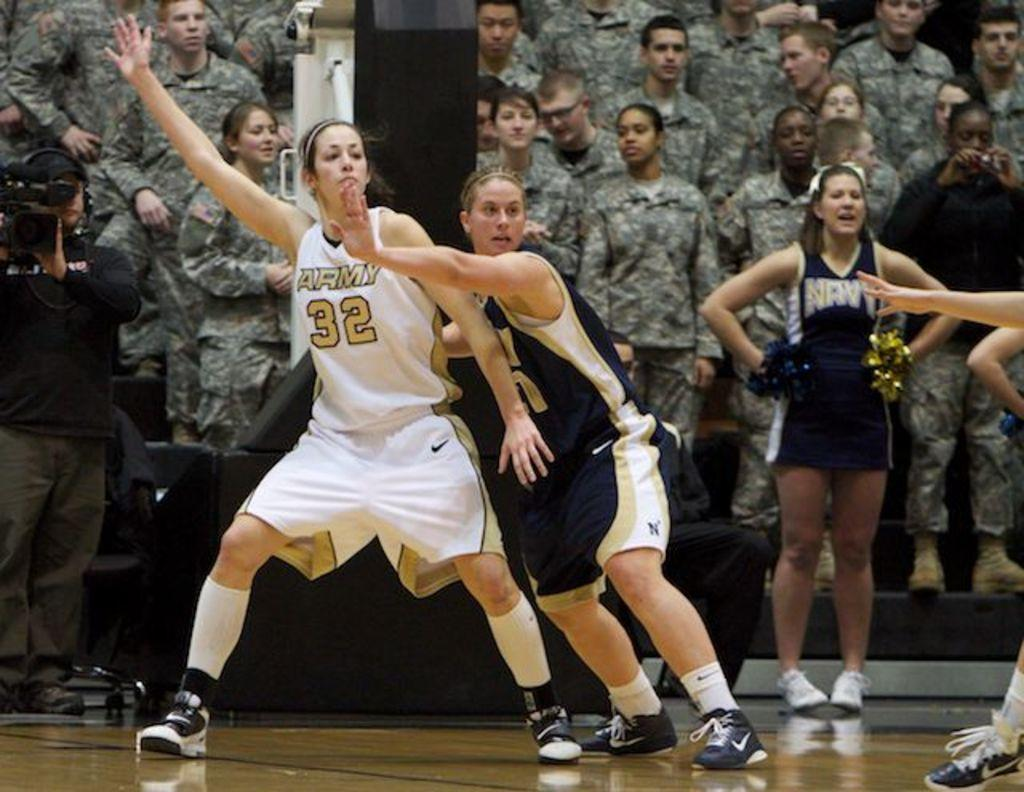<image>
Provide a brief description of the given image. Female ball players in a white uniform with Army in gold lettering on the front. 